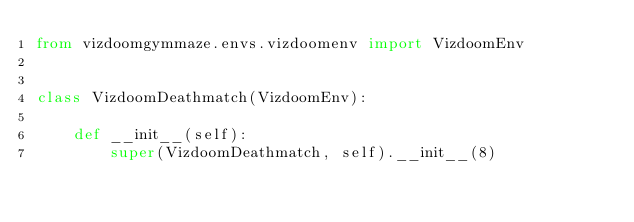Convert code to text. <code><loc_0><loc_0><loc_500><loc_500><_Python_>from vizdoomgymmaze.envs.vizdoomenv import VizdoomEnv


class VizdoomDeathmatch(VizdoomEnv):

    def __init__(self):
        super(VizdoomDeathmatch, self).__init__(8)
</code> 